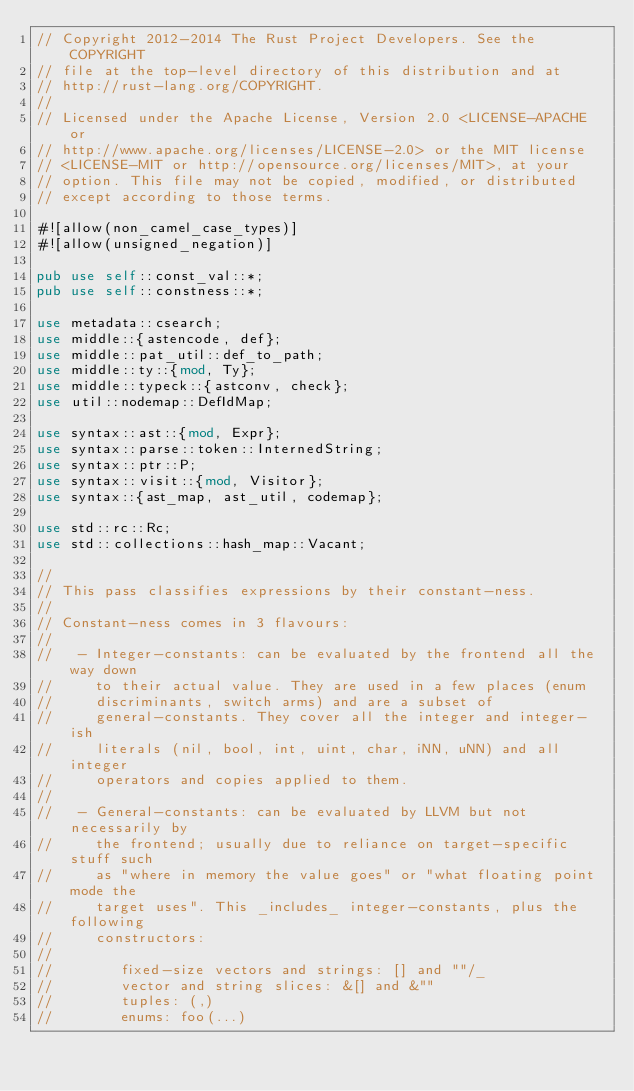Convert code to text. <code><loc_0><loc_0><loc_500><loc_500><_Rust_>// Copyright 2012-2014 The Rust Project Developers. See the COPYRIGHT
// file at the top-level directory of this distribution and at
// http://rust-lang.org/COPYRIGHT.
//
// Licensed under the Apache License, Version 2.0 <LICENSE-APACHE or
// http://www.apache.org/licenses/LICENSE-2.0> or the MIT license
// <LICENSE-MIT or http://opensource.org/licenses/MIT>, at your
// option. This file may not be copied, modified, or distributed
// except according to those terms.

#![allow(non_camel_case_types)]
#![allow(unsigned_negation)]

pub use self::const_val::*;
pub use self::constness::*;

use metadata::csearch;
use middle::{astencode, def};
use middle::pat_util::def_to_path;
use middle::ty::{mod, Ty};
use middle::typeck::{astconv, check};
use util::nodemap::DefIdMap;

use syntax::ast::{mod, Expr};
use syntax::parse::token::InternedString;
use syntax::ptr::P;
use syntax::visit::{mod, Visitor};
use syntax::{ast_map, ast_util, codemap};

use std::rc::Rc;
use std::collections::hash_map::Vacant;

//
// This pass classifies expressions by their constant-ness.
//
// Constant-ness comes in 3 flavours:
//
//   - Integer-constants: can be evaluated by the frontend all the way down
//     to their actual value. They are used in a few places (enum
//     discriminants, switch arms) and are a subset of
//     general-constants. They cover all the integer and integer-ish
//     literals (nil, bool, int, uint, char, iNN, uNN) and all integer
//     operators and copies applied to them.
//
//   - General-constants: can be evaluated by LLVM but not necessarily by
//     the frontend; usually due to reliance on target-specific stuff such
//     as "where in memory the value goes" or "what floating point mode the
//     target uses". This _includes_ integer-constants, plus the following
//     constructors:
//
//        fixed-size vectors and strings: [] and ""/_
//        vector and string slices: &[] and &""
//        tuples: (,)
//        enums: foo(...)</code> 